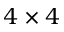Convert formula to latex. <formula><loc_0><loc_0><loc_500><loc_500>4 \times 4</formula> 